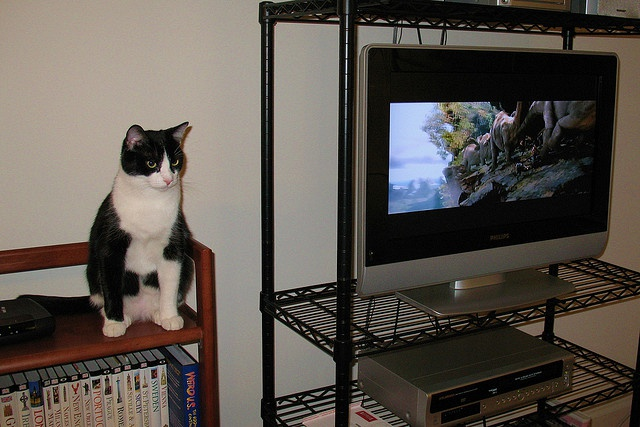Describe the objects in this image and their specific colors. I can see tv in gray, black, and lavender tones, cat in gray, black, darkgray, and tan tones, book in gray and darkgray tones, book in gray, black, navy, and purple tones, and book in gray and black tones in this image. 